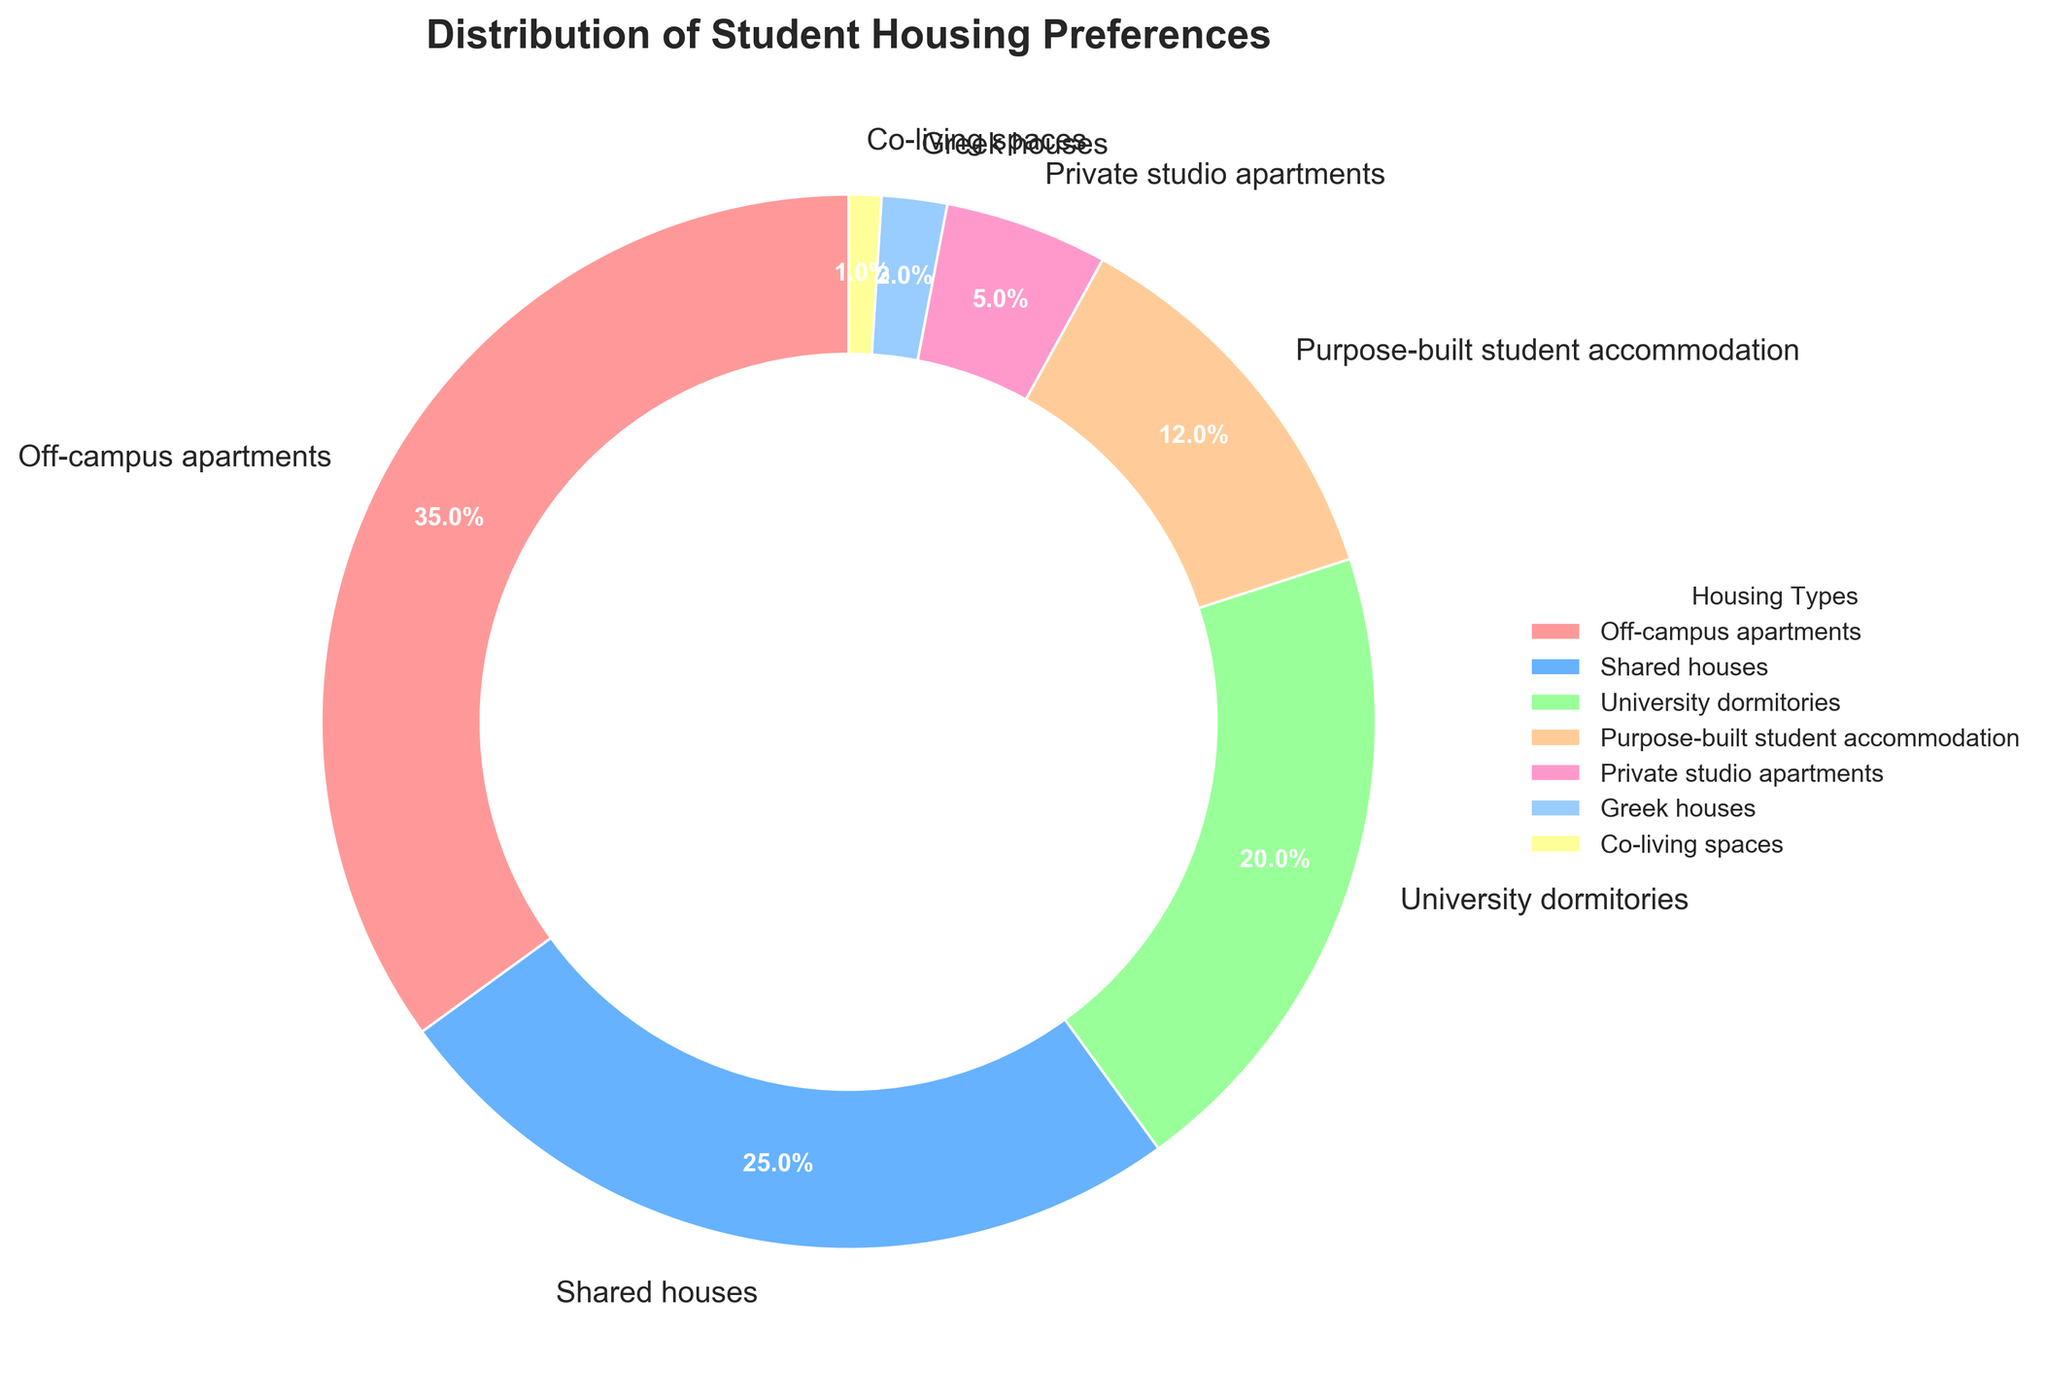What is the housing type preferred by the largest percentage of students? The slice labeled "Off-campus apartments" occupies the largest portion of the pie chart with 35%. This means it is the most preferred housing type among students.
Answer: Off-campus apartments By what percentage does the preference for shared houses exceed private studio apartments? The preference for shared houses is 25%, and for private studio apartments, it is 5%. Subtracting the latter from the former gives 25% - 5% = 20%.
Answer: 20% Which two housing types combined make up more than half of the total student preferences? The preferences for Off-campus apartments and Shared houses are 35% and 25% respectively. Adding these gives 35% + 25% = 60%, which is more than half of the total.
Answer: Off-campus apartments and Shared houses How much less is the preference for co-living spaces compared to university dormitories? The preference for co-living spaces is 1%, and for university dormitories, it is 20%. Subtracting the former from the latter gives 20% - 1% = 19%.
Answer: 19% What is the total percentage of students who prefer living in purpose-built student accommodation, private studio apartments, and Greek houses? Adding the percentages for purpose-built student accommodation (12%), private studio apartments (5%), and Greek houses (2%) gives 12% + 5% + 2% = 19%.
Answer: 19% Which housing type uses the green color in the chart? Each color slice represents a different housing type. The green-colored slice corresponds to "Shared houses," which is labeled accordingly and shows 25% preference.
Answer: Shared houses What percentage of students prefer university dormitories? The chart shows a slice labeled "University dormitories," which has a percentage value displayed as 20%.
Answer: 20% How does the preference for off-campus apartments compare to university dormitories? Off-campus apartments have a preference of 35% and university dormitories have 20%. Comparing these shows that off-campus apartments are preferred by a higher percentage of students.
Answer: Off-campus apartments are preferred more If you combine the preferences for Greek houses and co-living spaces, would their total preference exceed 5%? The preferences for Greek houses and co-living spaces are 2% and 1%, respectively. Adding these gives 2% + 1% = 3%, which does not exceed 5%.
Answer: No Which housing type is least preferred by students? The slice representing the least percentage of the pie chart is "Co-living spaces," which shows a preference of 1%.
Answer: Co-living spaces 